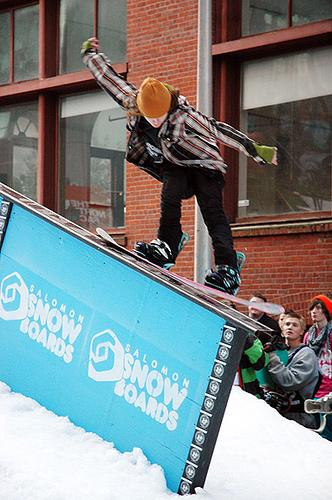What is this wall used for? Please explain your reasoning. snowboarding. The wall has a sign that says snowboard on it. 